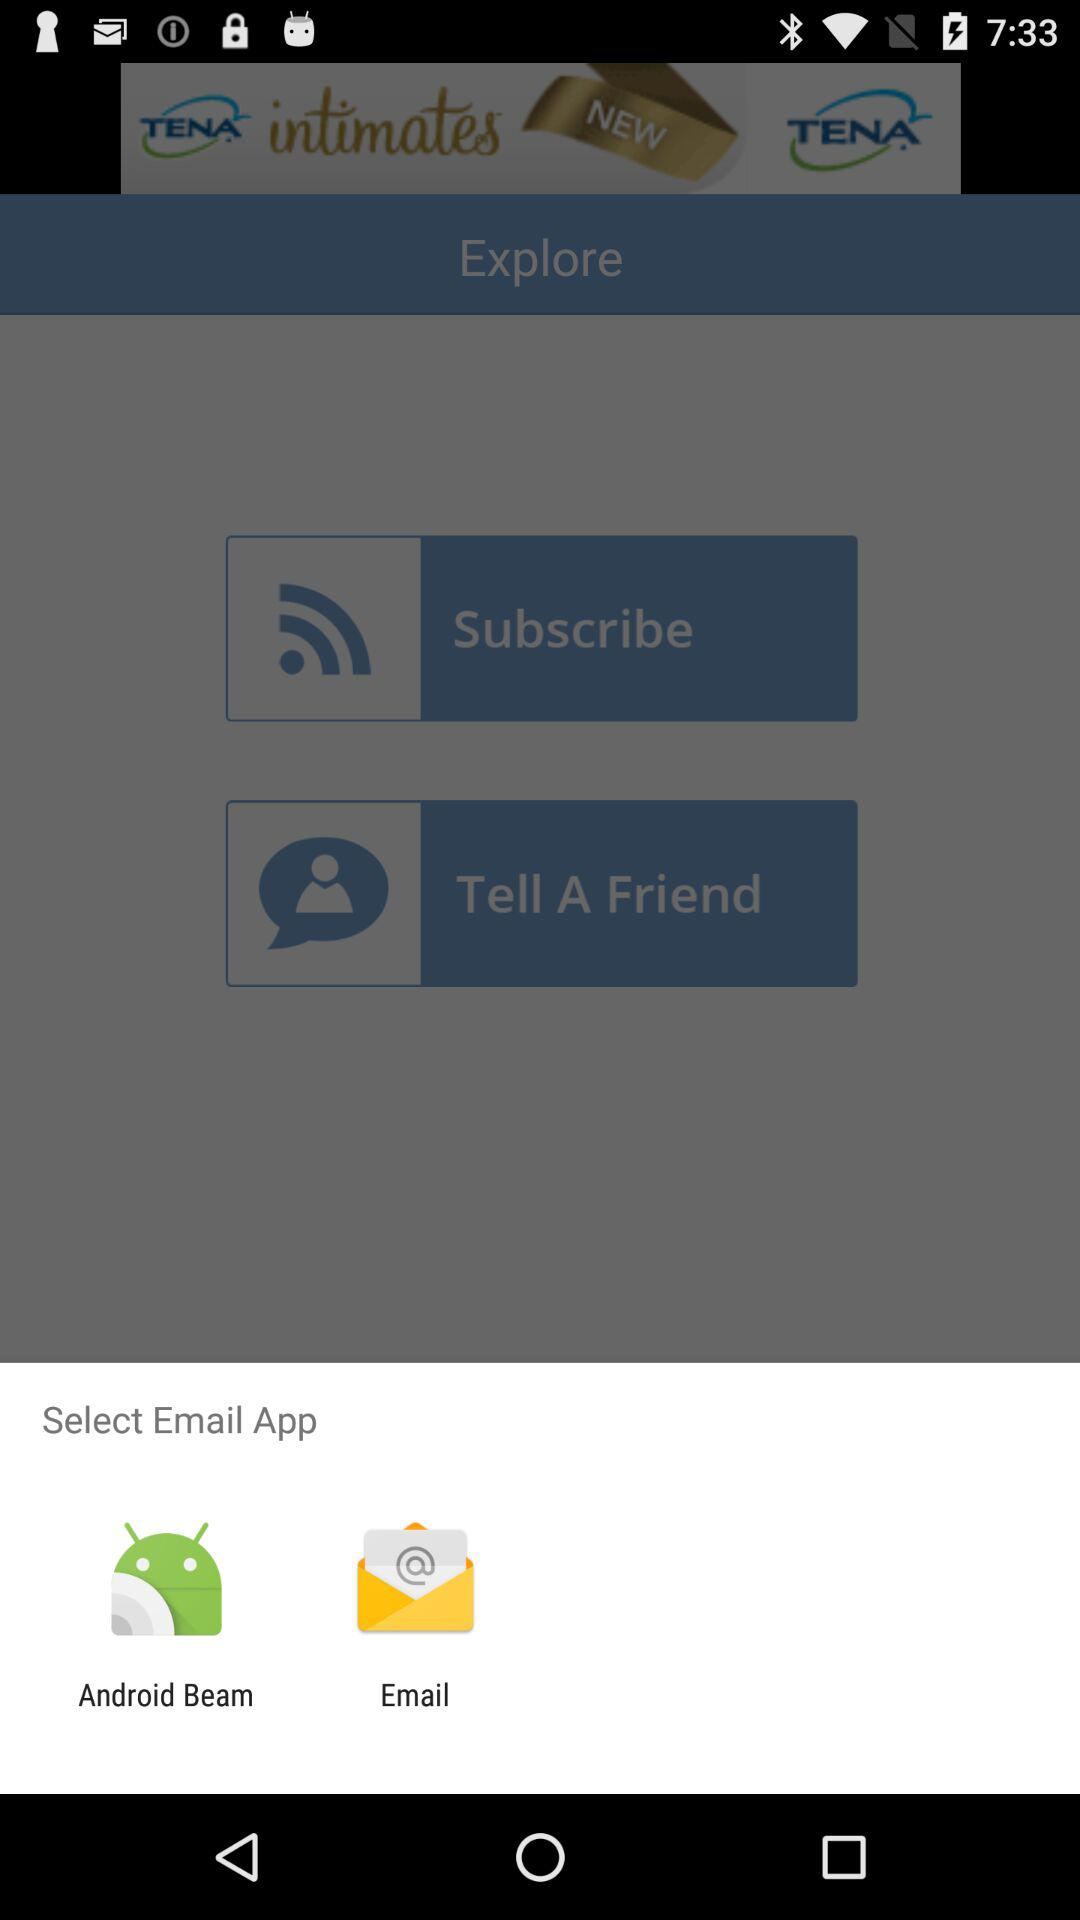What options are given for selecting? The options are "Android Beam" and "Email". 